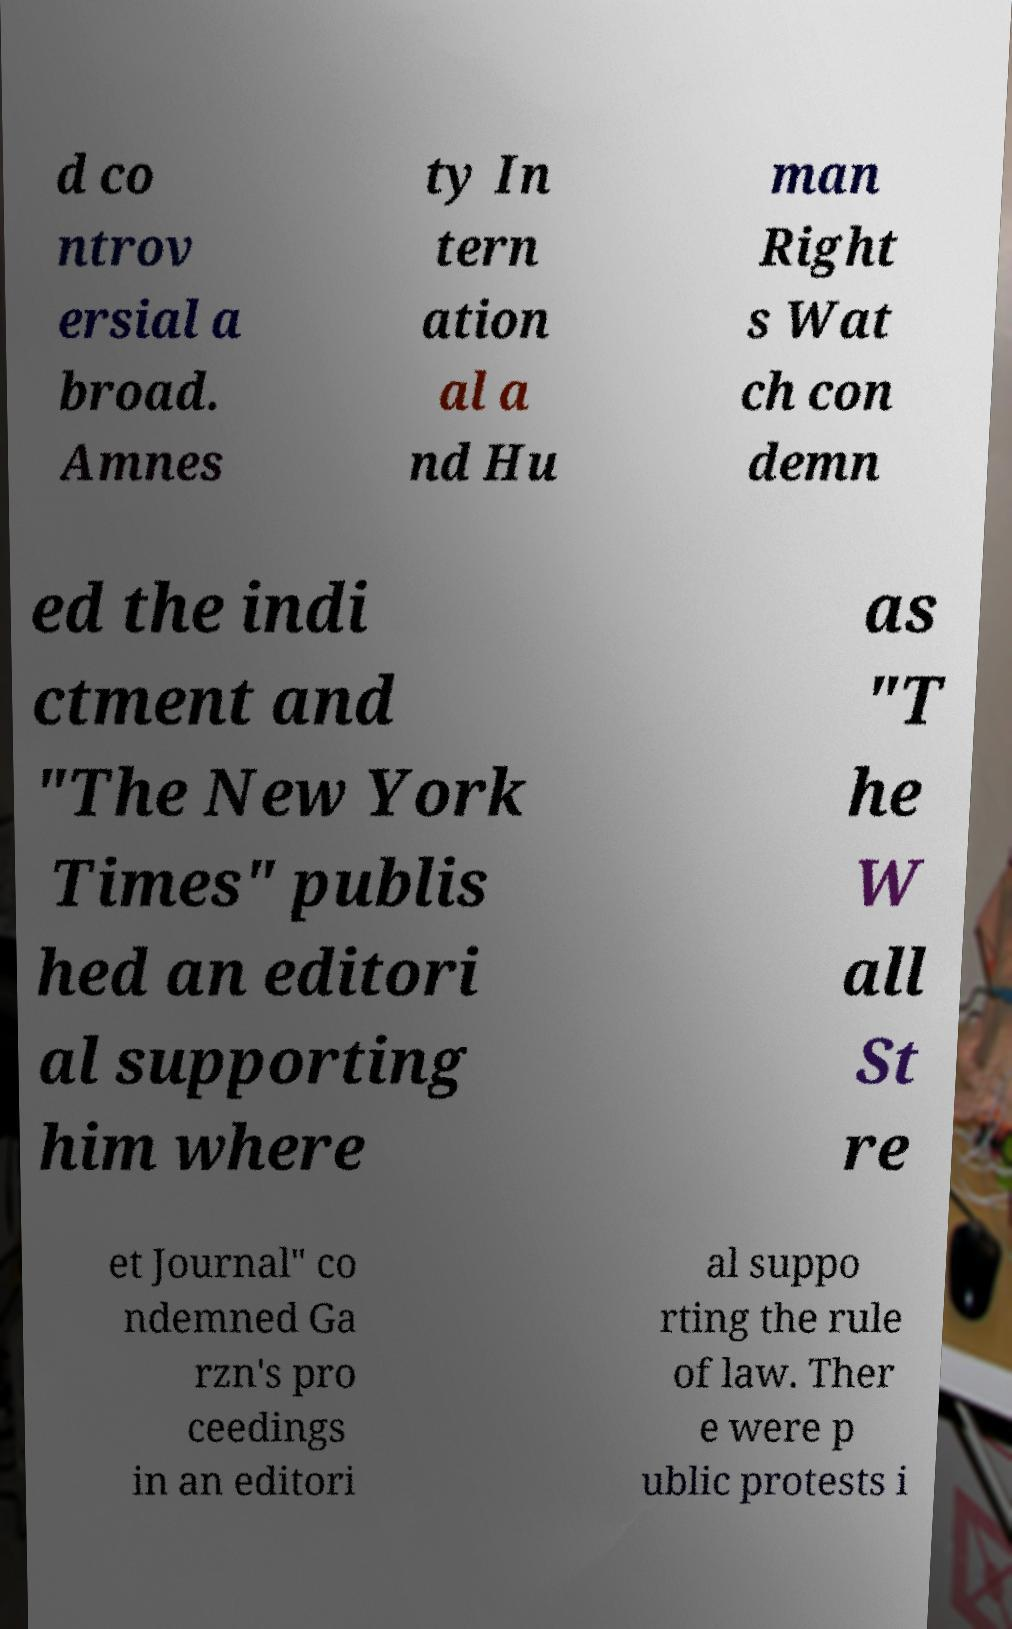For documentation purposes, I need the text within this image transcribed. Could you provide that? d co ntrov ersial a broad. Amnes ty In tern ation al a nd Hu man Right s Wat ch con demn ed the indi ctment and "The New York Times" publis hed an editori al supporting him where as "T he W all St re et Journal" co ndemned Ga rzn's pro ceedings in an editori al suppo rting the rule of law. Ther e were p ublic protests i 